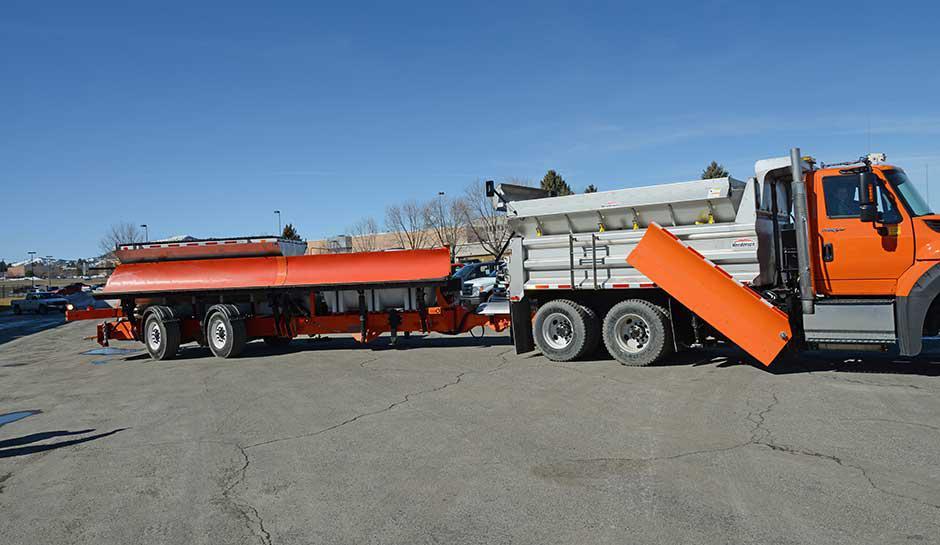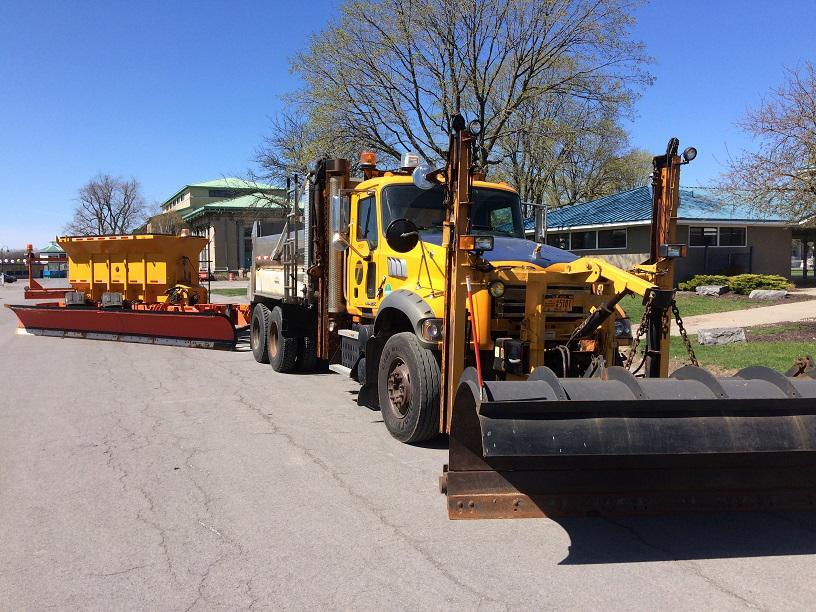The first image is the image on the left, the second image is the image on the right. Evaluate the accuracy of this statement regarding the images: "Snow is visible along the roadside in one of the images featuring a snow plow truck.". Is it true? Answer yes or no. No. The first image is the image on the left, the second image is the image on the right. Analyze the images presented: Is the assertion "In one image, at least one yellow truck with snow blade is on a snowy road, while a second image shows snow removal equipment on clear pavement." valid? Answer yes or no. No. 